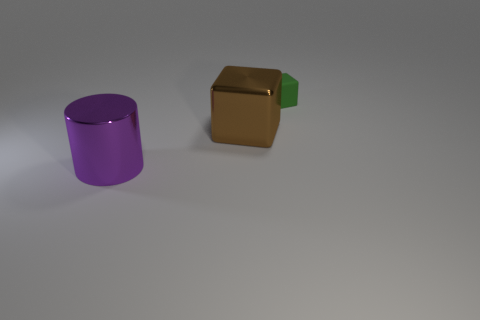There is a cube left of the green rubber cube; is its size the same as the rubber object?
Provide a succinct answer. No. There is a metallic object behind the large purple cylinder; what color is it?
Keep it short and to the point. Brown. The large object that is the same shape as the tiny object is what color?
Provide a short and direct response. Brown. What number of big shiny cylinders are in front of the cube that is in front of the block on the right side of the large brown object?
Your answer should be compact. 1. Is there anything else that has the same material as the small thing?
Give a very brief answer. No. Are there fewer tiny green cubes behind the green matte cube than big purple objects?
Provide a short and direct response. Yes. Do the large cube and the tiny object have the same color?
Offer a very short reply. No. There is another brown object that is the same shape as the tiny object; what is its size?
Your answer should be compact. Large. What number of blocks are the same material as the big cylinder?
Your answer should be very brief. 1. Do the cube that is in front of the rubber thing and the purple object have the same material?
Ensure brevity in your answer.  Yes. 